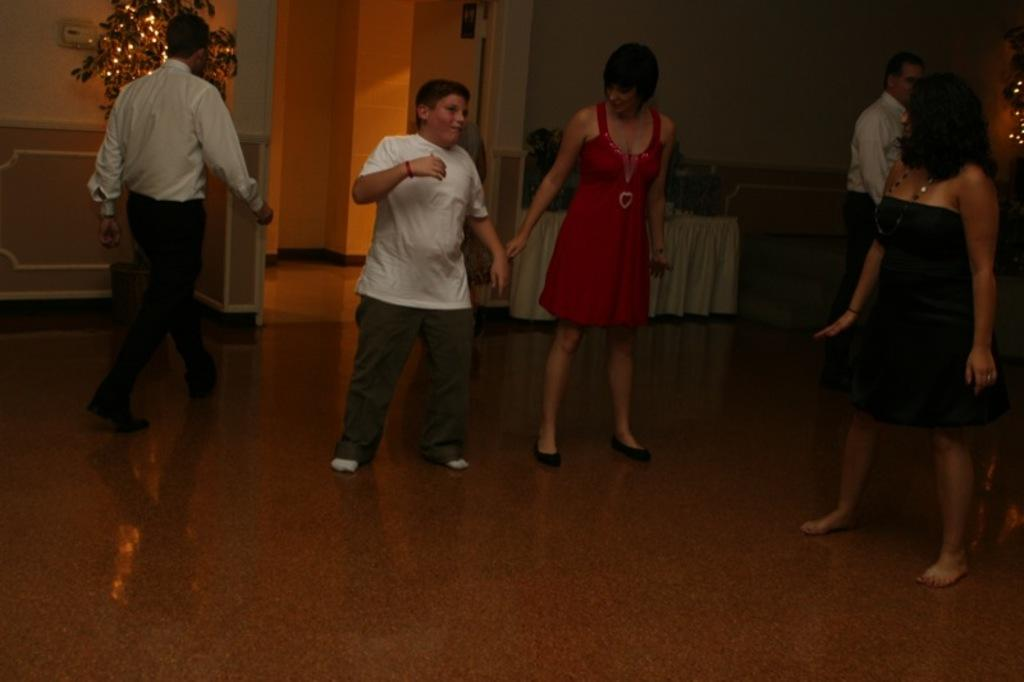What are the people in the image doing? The people in the image are standing on the floor. What can be seen in the background of the image? There is a wall in the background of the image. What is attached to the wall in the image? There are lights on the wall in the image. How many sheep are visible in the image? There are no sheep present in the image. What type of statement is being made by the people in the image? The image does not show any statements being made by the people; it only shows them standing on the floor. 